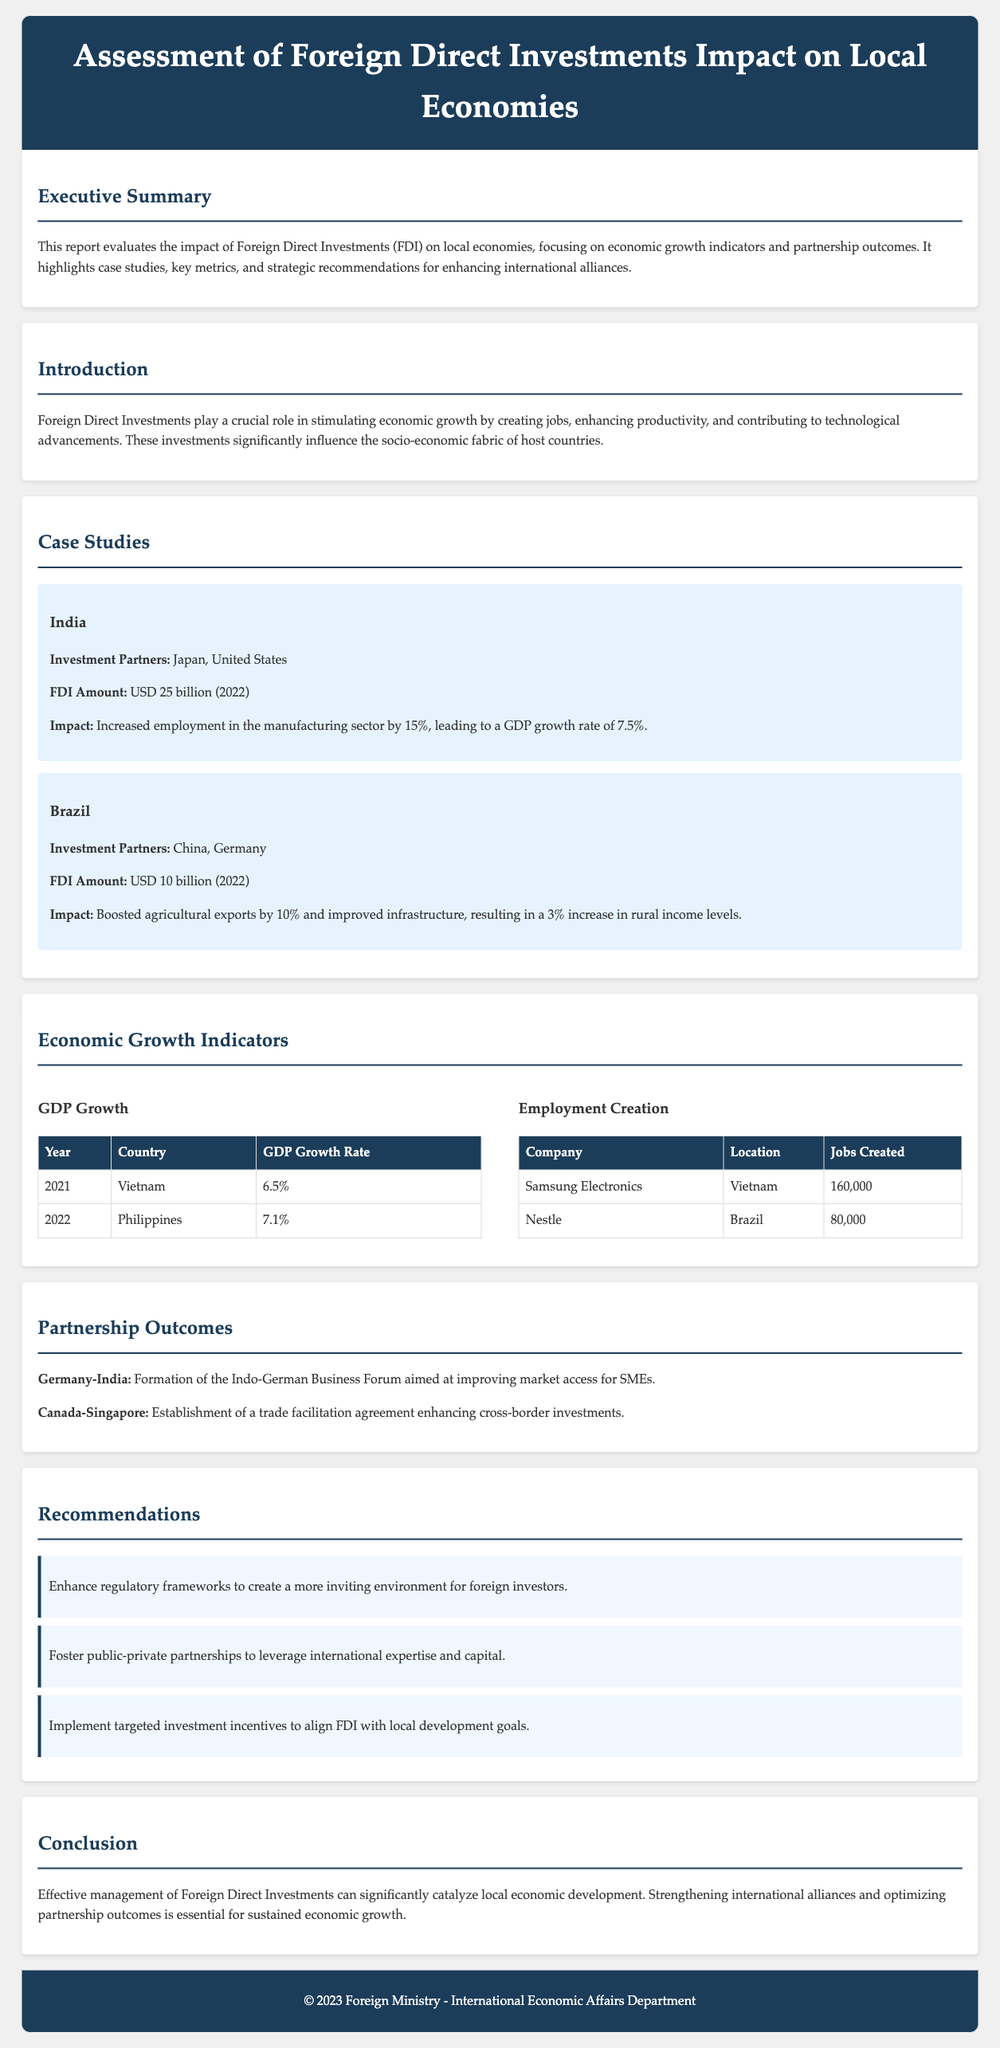What was the FDI amount in India for 2022? The FDI amount in India for 2022 is highlighted in the case study section.
Answer: USD 25 billion What was the GDP growth rate linked to manufacturing employment in India? The impact section in the case study details the GDP growth rate due to manufacturing employment.
Answer: 7.5% Which company created 160,000 jobs in Vietnam? The employment creation table lists companies along with jobs created, specifying Samsung Electronics in Vietnam.
Answer: Samsung Electronics What strategic partnership was formed between Germany and India? The partnership outcomes section mentions the formation of specific business forums or agreements between countries.
Answer: Indo-German Business Forum What is one recommendation for enhancing FDI listed in the report? The recommendations section provides strategic suggestions to improve the environment for FDI.
Answer: Enhance regulatory frameworks What was the increase in agricultural exports in Brazil due to FDI? The impact of FDI in the Brazil case study provides details on export growth statistics.
Answer: 10% What year showed a GDP growth rate of 6.5%? The GDP growth table lists years along with the countries and their corresponding GDP growth rates.
Answer: 2021 Which country partnered with Canada to establish a trade facilitation agreement? The partnership outcomes section specifies which countries are involved in specific agreements.
Answer: Singapore 